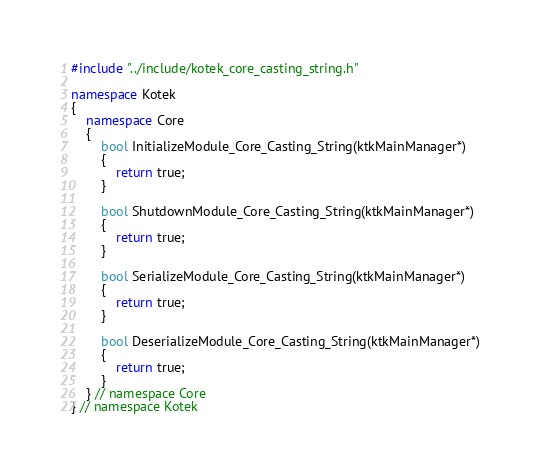Convert code to text. <code><loc_0><loc_0><loc_500><loc_500><_C++_>#include "../include/kotek_core_casting_string.h"

namespace Kotek
{
	namespace Core
	{
		bool InitializeModule_Core_Casting_String(ktkMainManager*)
		{
			return true;
		}

		bool ShutdownModule_Core_Casting_String(ktkMainManager*)
		{
			return true;
		}

		bool SerializeModule_Core_Casting_String(ktkMainManager*)
		{
			return true;
		}

		bool DeserializeModule_Core_Casting_String(ktkMainManager*)
		{
			return true;
		}
	} // namespace Core
} // namespace Kotek</code> 